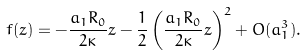<formula> <loc_0><loc_0><loc_500><loc_500>f ( z ) = - \frac { a _ { 1 } R _ { 0 } } { 2 \kappa } z - \frac { 1 } { 2 } \left ( \frac { a _ { 1 } R _ { 0 } } { 2 \kappa } z \right ) ^ { 2 } + O ( a _ { 1 } ^ { 3 } ) .</formula> 